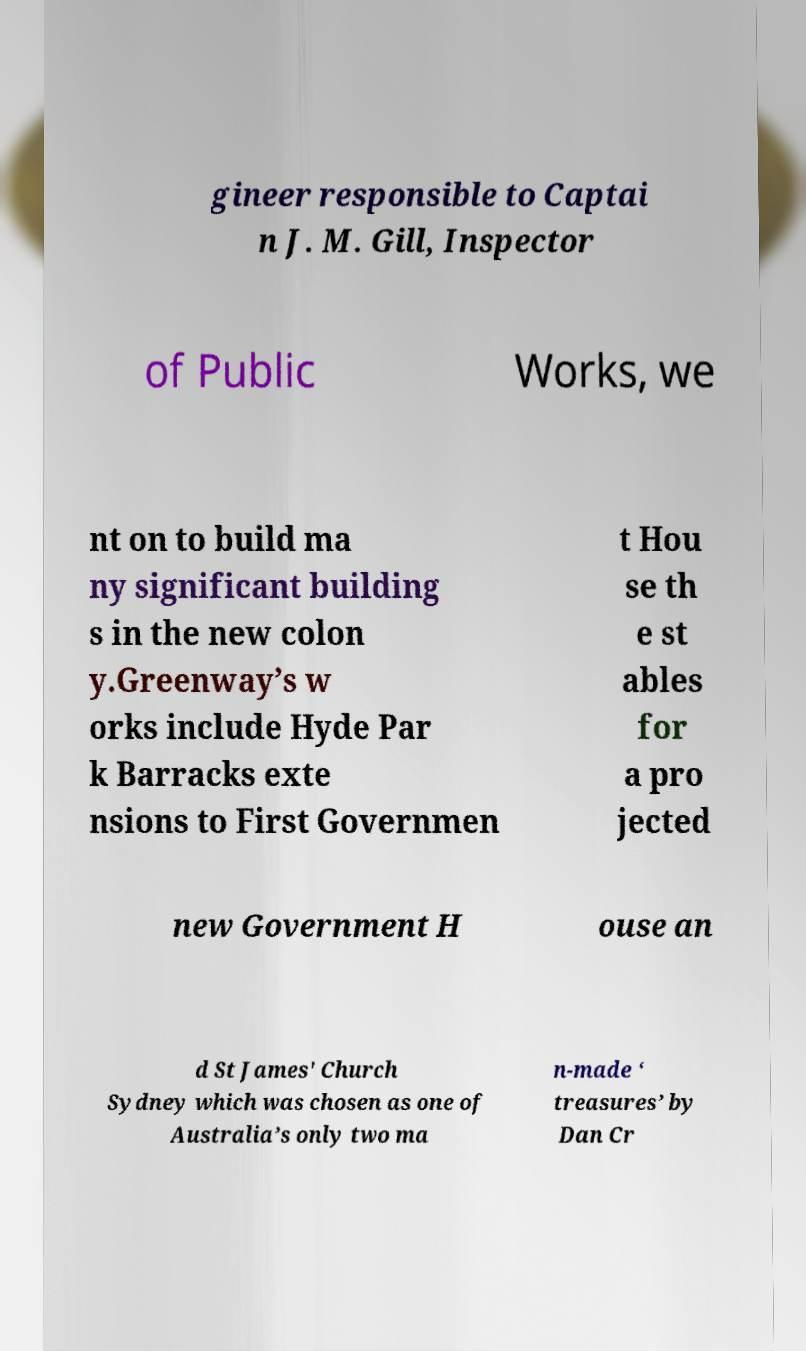What messages or text are displayed in this image? I need them in a readable, typed format. gineer responsible to Captai n J. M. Gill, Inspector of Public Works, we nt on to build ma ny significant building s in the new colon y.Greenway’s w orks include Hyde Par k Barracks exte nsions to First Governmen t Hou se th e st ables for a pro jected new Government H ouse an d St James' Church Sydney which was chosen as one of Australia’s only two ma n-made ‘ treasures’ by Dan Cr 